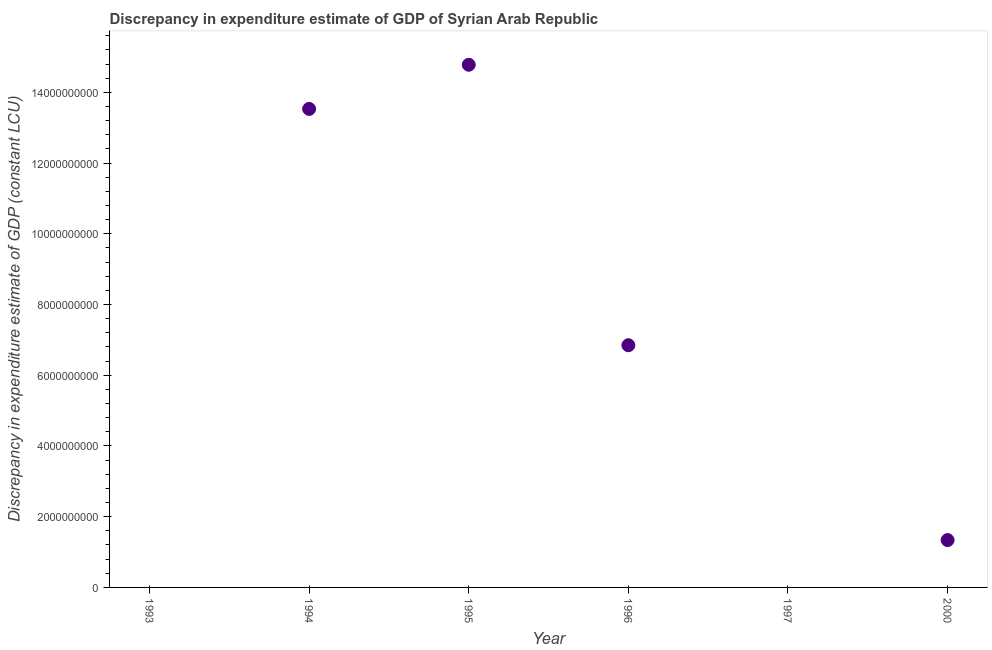Across all years, what is the maximum discrepancy in expenditure estimate of gdp?
Offer a very short reply. 1.48e+1. What is the sum of the discrepancy in expenditure estimate of gdp?
Offer a very short reply. 3.65e+1. What is the difference between the discrepancy in expenditure estimate of gdp in 1994 and 1995?
Provide a short and direct response. -1.25e+09. What is the average discrepancy in expenditure estimate of gdp per year?
Make the answer very short. 6.08e+09. What is the median discrepancy in expenditure estimate of gdp?
Offer a very short reply. 4.09e+09. In how many years, is the discrepancy in expenditure estimate of gdp greater than 14000000000 LCU?
Provide a succinct answer. 1. What is the ratio of the discrepancy in expenditure estimate of gdp in 1996 to that in 2000?
Keep it short and to the point. 5.12. Is the discrepancy in expenditure estimate of gdp in 1994 less than that in 1996?
Offer a very short reply. No. What is the difference between the highest and the second highest discrepancy in expenditure estimate of gdp?
Your answer should be compact. 1.25e+09. What is the difference between the highest and the lowest discrepancy in expenditure estimate of gdp?
Give a very brief answer. 1.48e+1. How many years are there in the graph?
Offer a very short reply. 6. What is the difference between two consecutive major ticks on the Y-axis?
Provide a succinct answer. 2.00e+09. Does the graph contain any zero values?
Give a very brief answer. Yes. What is the title of the graph?
Make the answer very short. Discrepancy in expenditure estimate of GDP of Syrian Arab Republic. What is the label or title of the Y-axis?
Provide a succinct answer. Discrepancy in expenditure estimate of GDP (constant LCU). What is the Discrepancy in expenditure estimate of GDP (constant LCU) in 1994?
Offer a terse response. 1.35e+1. What is the Discrepancy in expenditure estimate of GDP (constant LCU) in 1995?
Ensure brevity in your answer.  1.48e+1. What is the Discrepancy in expenditure estimate of GDP (constant LCU) in 1996?
Ensure brevity in your answer.  6.85e+09. What is the Discrepancy in expenditure estimate of GDP (constant LCU) in 1997?
Your answer should be compact. 0. What is the Discrepancy in expenditure estimate of GDP (constant LCU) in 2000?
Your response must be concise. 1.34e+09. What is the difference between the Discrepancy in expenditure estimate of GDP (constant LCU) in 1994 and 1995?
Keep it short and to the point. -1.25e+09. What is the difference between the Discrepancy in expenditure estimate of GDP (constant LCU) in 1994 and 1996?
Provide a succinct answer. 6.68e+09. What is the difference between the Discrepancy in expenditure estimate of GDP (constant LCU) in 1994 and 2000?
Offer a terse response. 1.22e+1. What is the difference between the Discrepancy in expenditure estimate of GDP (constant LCU) in 1995 and 1996?
Your answer should be very brief. 7.93e+09. What is the difference between the Discrepancy in expenditure estimate of GDP (constant LCU) in 1995 and 2000?
Give a very brief answer. 1.34e+1. What is the difference between the Discrepancy in expenditure estimate of GDP (constant LCU) in 1996 and 2000?
Keep it short and to the point. 5.51e+09. What is the ratio of the Discrepancy in expenditure estimate of GDP (constant LCU) in 1994 to that in 1995?
Make the answer very short. 0.92. What is the ratio of the Discrepancy in expenditure estimate of GDP (constant LCU) in 1994 to that in 1996?
Make the answer very short. 1.98. What is the ratio of the Discrepancy in expenditure estimate of GDP (constant LCU) in 1994 to that in 2000?
Provide a succinct answer. 10.11. What is the ratio of the Discrepancy in expenditure estimate of GDP (constant LCU) in 1995 to that in 1996?
Provide a short and direct response. 2.16. What is the ratio of the Discrepancy in expenditure estimate of GDP (constant LCU) in 1995 to that in 2000?
Keep it short and to the point. 11.04. What is the ratio of the Discrepancy in expenditure estimate of GDP (constant LCU) in 1996 to that in 2000?
Offer a terse response. 5.12. 